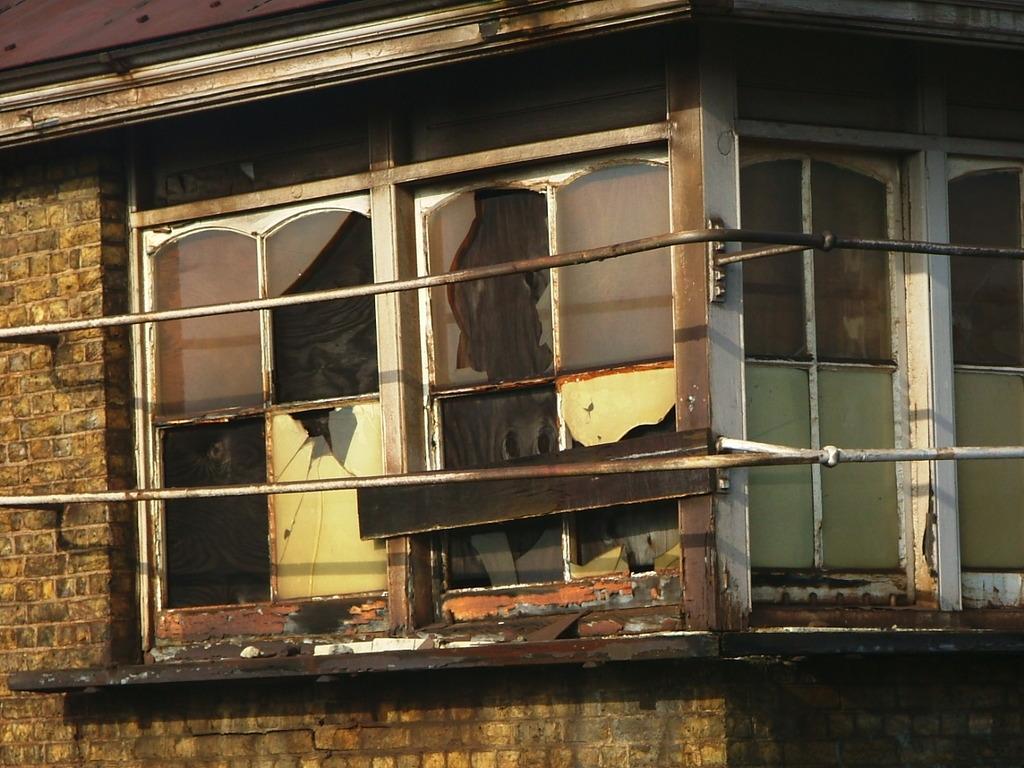Can you describe this image briefly? In this image there is a house with windows and broken glass. 